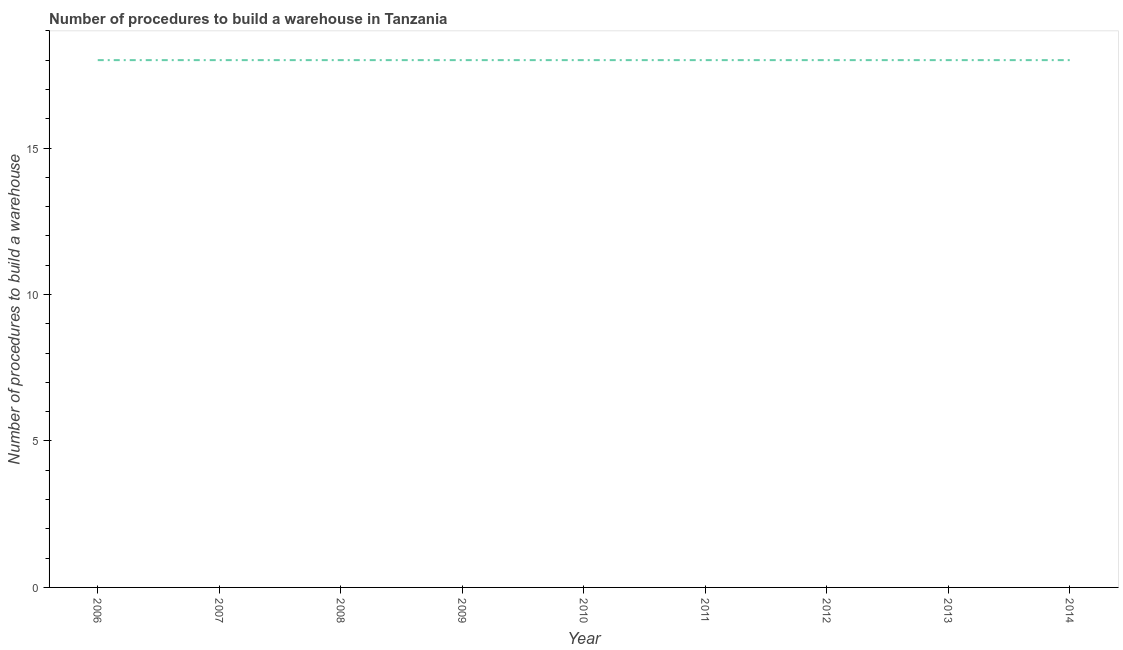What is the number of procedures to build a warehouse in 2007?
Your answer should be very brief. 18. Across all years, what is the maximum number of procedures to build a warehouse?
Keep it short and to the point. 18. Across all years, what is the minimum number of procedures to build a warehouse?
Offer a very short reply. 18. In which year was the number of procedures to build a warehouse minimum?
Your answer should be compact. 2006. What is the sum of the number of procedures to build a warehouse?
Make the answer very short. 162. What is the median number of procedures to build a warehouse?
Provide a short and direct response. 18. In how many years, is the number of procedures to build a warehouse greater than 9 ?
Your response must be concise. 9. Do a majority of the years between 2006 and 2014 (inclusive) have number of procedures to build a warehouse greater than 12 ?
Ensure brevity in your answer.  Yes. What is the ratio of the number of procedures to build a warehouse in 2007 to that in 2008?
Keep it short and to the point. 1. What is the difference between the highest and the second highest number of procedures to build a warehouse?
Provide a succinct answer. 0. Is the sum of the number of procedures to build a warehouse in 2006 and 2009 greater than the maximum number of procedures to build a warehouse across all years?
Provide a succinct answer. Yes. In how many years, is the number of procedures to build a warehouse greater than the average number of procedures to build a warehouse taken over all years?
Give a very brief answer. 0. Does the number of procedures to build a warehouse monotonically increase over the years?
Your answer should be compact. No. How many lines are there?
Offer a very short reply. 1. What is the difference between two consecutive major ticks on the Y-axis?
Make the answer very short. 5. Does the graph contain any zero values?
Keep it short and to the point. No. Does the graph contain grids?
Provide a succinct answer. No. What is the title of the graph?
Your answer should be compact. Number of procedures to build a warehouse in Tanzania. What is the label or title of the X-axis?
Provide a succinct answer. Year. What is the label or title of the Y-axis?
Give a very brief answer. Number of procedures to build a warehouse. What is the Number of procedures to build a warehouse in 2006?
Offer a terse response. 18. What is the Number of procedures to build a warehouse in 2007?
Offer a very short reply. 18. What is the Number of procedures to build a warehouse in 2010?
Offer a very short reply. 18. What is the Number of procedures to build a warehouse of 2011?
Provide a short and direct response. 18. What is the Number of procedures to build a warehouse in 2012?
Give a very brief answer. 18. What is the Number of procedures to build a warehouse in 2013?
Provide a succinct answer. 18. What is the difference between the Number of procedures to build a warehouse in 2006 and 2011?
Your answer should be very brief. 0. What is the difference between the Number of procedures to build a warehouse in 2006 and 2012?
Keep it short and to the point. 0. What is the difference between the Number of procedures to build a warehouse in 2006 and 2013?
Your answer should be compact. 0. What is the difference between the Number of procedures to build a warehouse in 2007 and 2010?
Ensure brevity in your answer.  0. What is the difference between the Number of procedures to build a warehouse in 2007 and 2013?
Provide a short and direct response. 0. What is the difference between the Number of procedures to build a warehouse in 2008 and 2012?
Your answer should be very brief. 0. What is the difference between the Number of procedures to build a warehouse in 2008 and 2013?
Offer a very short reply. 0. What is the difference between the Number of procedures to build a warehouse in 2009 and 2010?
Your answer should be very brief. 0. What is the difference between the Number of procedures to build a warehouse in 2009 and 2012?
Your response must be concise. 0. What is the difference between the Number of procedures to build a warehouse in 2009 and 2013?
Give a very brief answer. 0. What is the difference between the Number of procedures to build a warehouse in 2009 and 2014?
Offer a terse response. 0. What is the difference between the Number of procedures to build a warehouse in 2010 and 2011?
Ensure brevity in your answer.  0. What is the difference between the Number of procedures to build a warehouse in 2010 and 2013?
Your answer should be compact. 0. What is the difference between the Number of procedures to build a warehouse in 2011 and 2013?
Keep it short and to the point. 0. What is the difference between the Number of procedures to build a warehouse in 2011 and 2014?
Your answer should be compact. 0. What is the difference between the Number of procedures to build a warehouse in 2012 and 2013?
Your answer should be compact. 0. What is the difference between the Number of procedures to build a warehouse in 2012 and 2014?
Make the answer very short. 0. What is the ratio of the Number of procedures to build a warehouse in 2006 to that in 2007?
Provide a succinct answer. 1. What is the ratio of the Number of procedures to build a warehouse in 2006 to that in 2008?
Your answer should be compact. 1. What is the ratio of the Number of procedures to build a warehouse in 2006 to that in 2010?
Offer a very short reply. 1. What is the ratio of the Number of procedures to build a warehouse in 2006 to that in 2011?
Offer a very short reply. 1. What is the ratio of the Number of procedures to build a warehouse in 2006 to that in 2013?
Give a very brief answer. 1. What is the ratio of the Number of procedures to build a warehouse in 2007 to that in 2008?
Keep it short and to the point. 1. What is the ratio of the Number of procedures to build a warehouse in 2007 to that in 2009?
Give a very brief answer. 1. What is the ratio of the Number of procedures to build a warehouse in 2007 to that in 2013?
Provide a short and direct response. 1. What is the ratio of the Number of procedures to build a warehouse in 2008 to that in 2009?
Ensure brevity in your answer.  1. What is the ratio of the Number of procedures to build a warehouse in 2008 to that in 2011?
Your answer should be very brief. 1. What is the ratio of the Number of procedures to build a warehouse in 2008 to that in 2013?
Make the answer very short. 1. What is the ratio of the Number of procedures to build a warehouse in 2008 to that in 2014?
Your response must be concise. 1. What is the ratio of the Number of procedures to build a warehouse in 2009 to that in 2010?
Keep it short and to the point. 1. What is the ratio of the Number of procedures to build a warehouse in 2009 to that in 2011?
Keep it short and to the point. 1. What is the ratio of the Number of procedures to build a warehouse in 2009 to that in 2012?
Your response must be concise. 1. What is the ratio of the Number of procedures to build a warehouse in 2009 to that in 2013?
Your answer should be compact. 1. What is the ratio of the Number of procedures to build a warehouse in 2009 to that in 2014?
Provide a succinct answer. 1. What is the ratio of the Number of procedures to build a warehouse in 2010 to that in 2012?
Offer a very short reply. 1. What is the ratio of the Number of procedures to build a warehouse in 2010 to that in 2014?
Your answer should be very brief. 1. What is the ratio of the Number of procedures to build a warehouse in 2011 to that in 2012?
Offer a terse response. 1. What is the ratio of the Number of procedures to build a warehouse in 2011 to that in 2013?
Your answer should be compact. 1. What is the ratio of the Number of procedures to build a warehouse in 2011 to that in 2014?
Give a very brief answer. 1. What is the ratio of the Number of procedures to build a warehouse in 2012 to that in 2013?
Provide a succinct answer. 1. What is the ratio of the Number of procedures to build a warehouse in 2012 to that in 2014?
Your response must be concise. 1. 